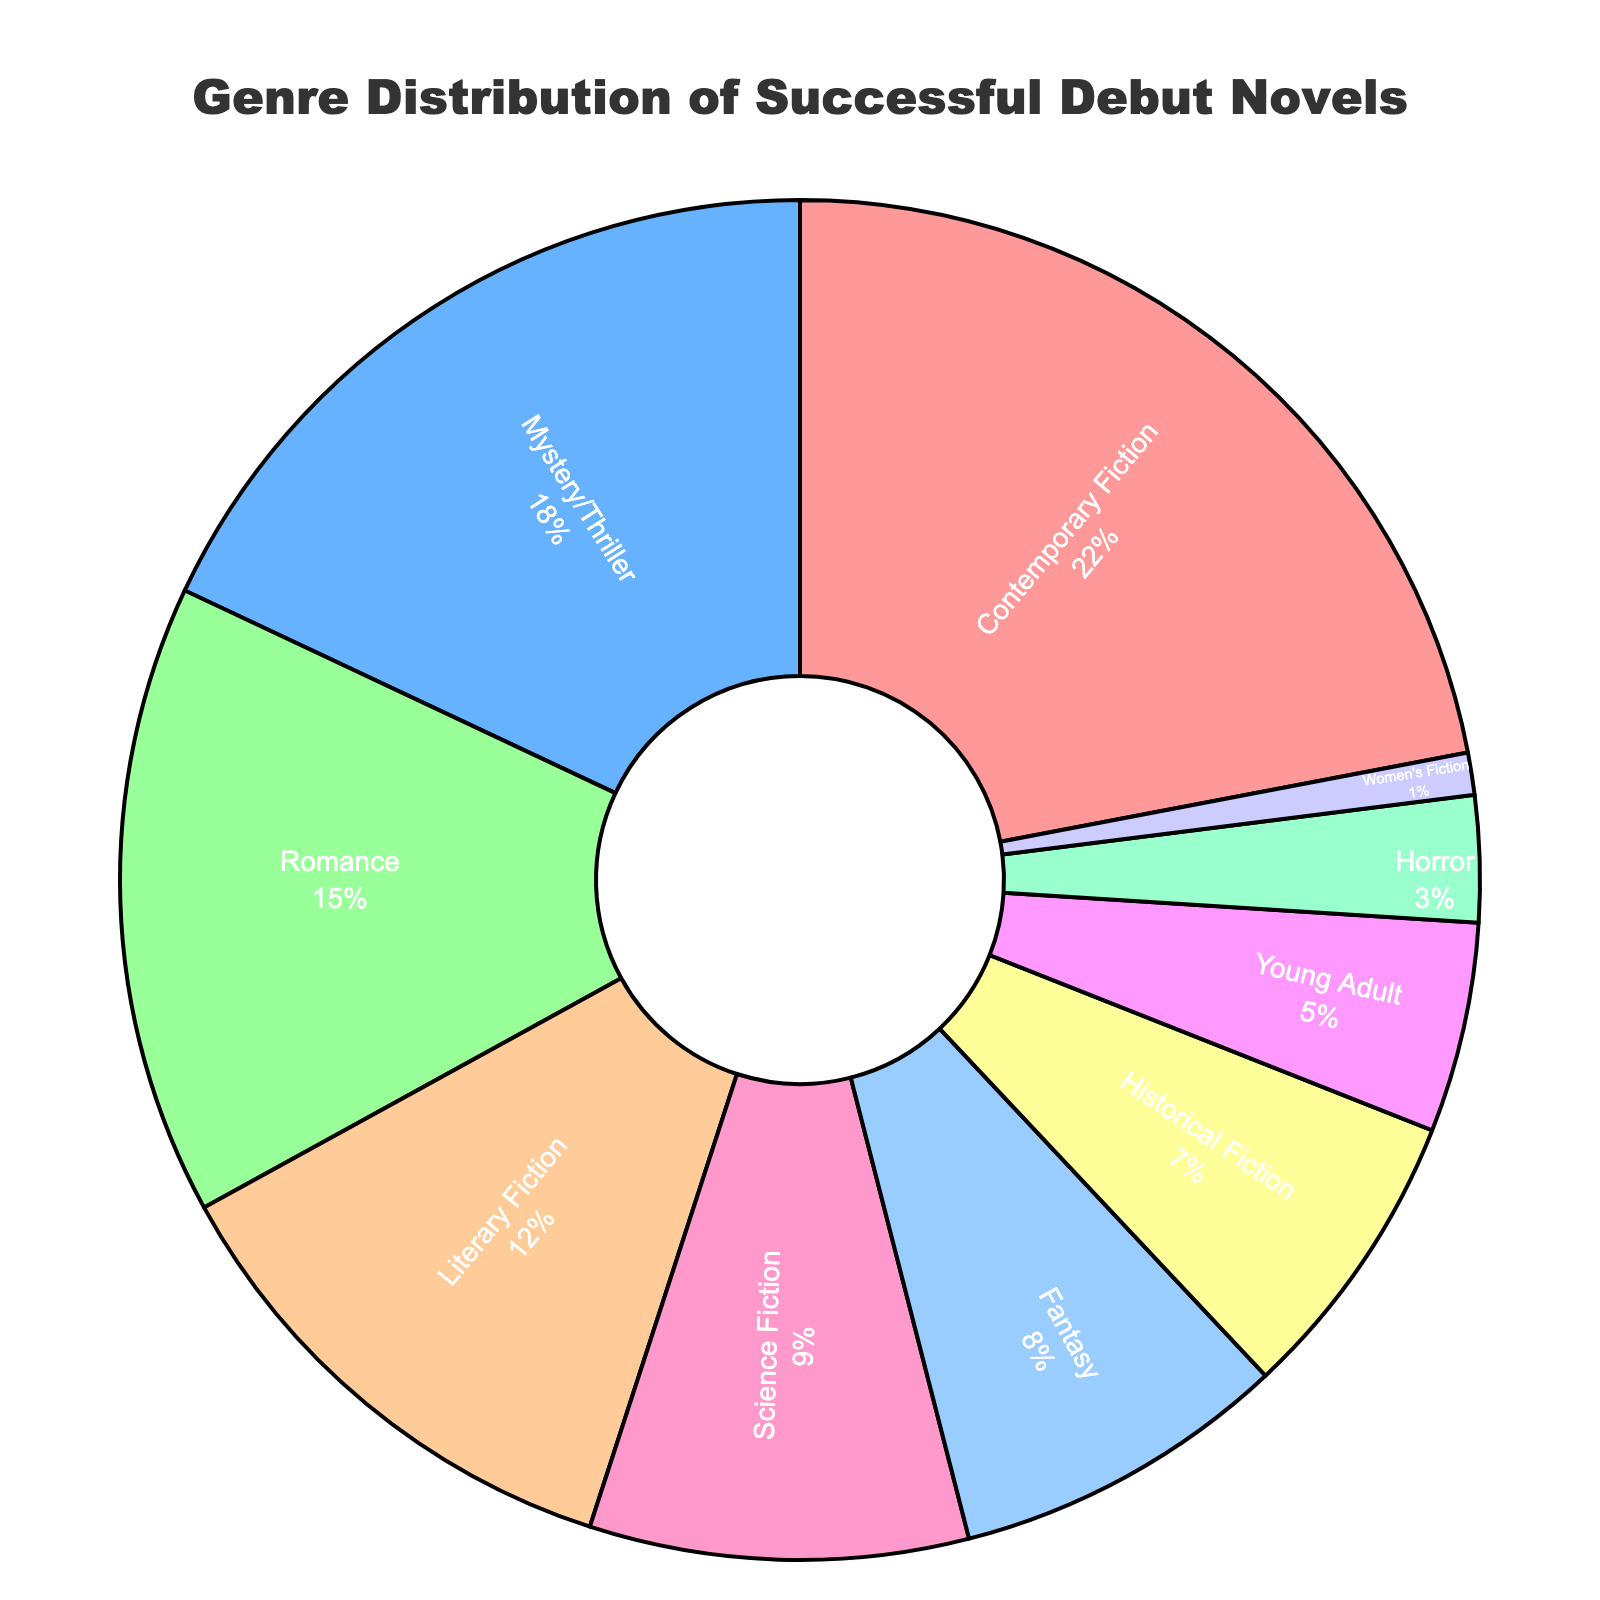What's the most represented genre in the pie chart? The most represented genre is the one with the highest percentage. Looking at the pie chart, Contemporary Fiction has the largest slice.
Answer: Contemporary Fiction Which two genres together make up exactly one-third of the distribution? To find two genres that together make up one-third (33.33%) of the distribution, we need to sum the percentages of different pairs. Mystery/Thriller (18%) and Romance (15%) add up to 33%.
Answer: Mystery/Thriller and Romance What is the difference in percentage between Contemporary Fiction and Historical Fiction? Subtract the percentage of Historical Fiction (7%) from Contemporary Fiction (22%). The difference is 22% - 7% = 15%.
Answer: 15% How many genres individually contribute less than 10%? Count the segments in the pie chart that are less than 10%. These genres are Science Fiction (9%), Fantasy (8%), Historical Fiction (7%), Young Adult (5%), Horror (3%), and Women's Fiction (1%). There are 6 genres.
Answer: 6 Which genre is represented by the green color in the pie chart? Identify the color green in the pie chart. Science Fiction is marked by the green color.
Answer: Science Fiction Is Romance more or less represented than Mystery/Thriller? Compare the percentages for Romance (15%) and Mystery/Thriller (18%). Romance is less represented.
Answer: Less What is the combined percentage of Literary Fiction, Fantasy, and Young Adult genres? Add the percentages of Literary Fiction (12%), Fantasy (8%), and Young Adult (5%). The combined value is 12% + 8% + 5% = 25%.
Answer: 25% Which genre has the smallest representation, and what is its percentage? Look for the smallest slice in the pie chart. Women's Fiction has the smallest representation at 1%.
Answer: Women's Fiction, 1% Compare the total percentage of genre categories that are at or above 15% to those below 15%? Sum the percentages at or above 15% (Contemporary Fiction 22%, Mystery/Thriller 18%, Romance 15%) and compare it to the sum of those below 15% (Literary Fiction 12%, Science Fiction 9%, Fantasy 8%, Historical Fiction 7%, Young Adult 5%, Horror 3%, Women's Fiction 1%). The totals are 22% + 18% + 15% = 55% for at or above 15%, and 12% + 9% + 8% + 7% + 5% + 3% + 1% = 45% for below 15%.
Answer: At or above 15%: 55%, Below 15%: 45% 